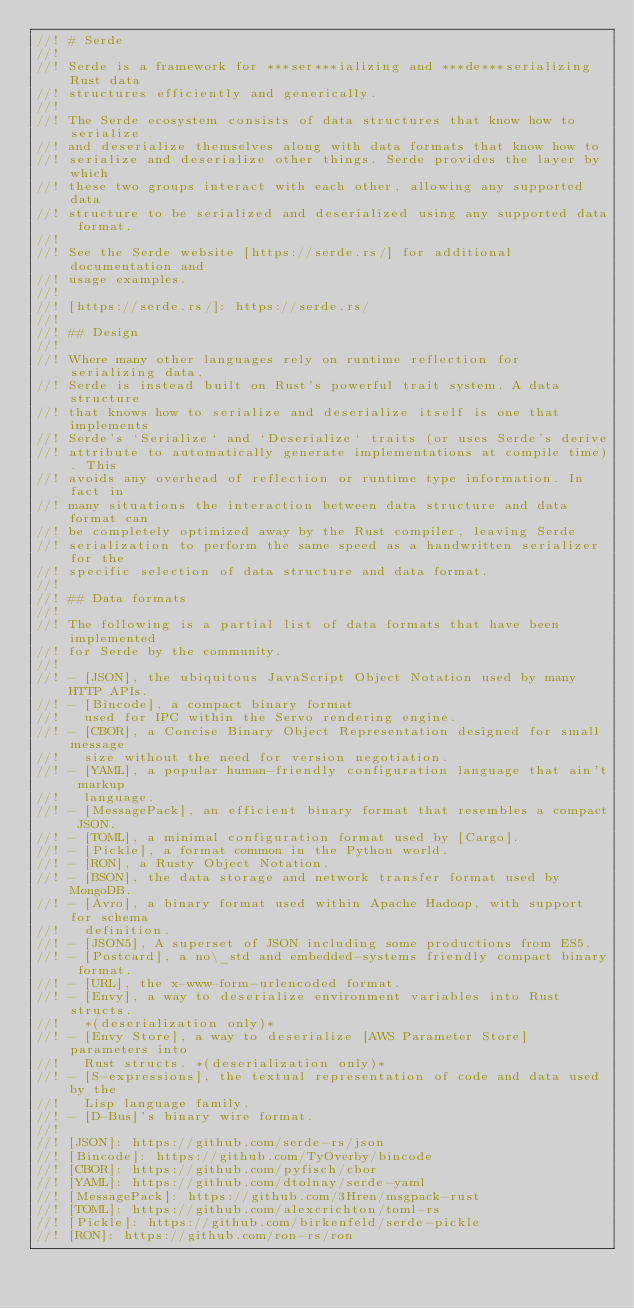Convert code to text. <code><loc_0><loc_0><loc_500><loc_500><_Rust_>//! # Serde
//!
//! Serde is a framework for ***ser***ializing and ***de***serializing Rust data
//! structures efficiently and generically.
//!
//! The Serde ecosystem consists of data structures that know how to serialize
//! and deserialize themselves along with data formats that know how to
//! serialize and deserialize other things. Serde provides the layer by which
//! these two groups interact with each other, allowing any supported data
//! structure to be serialized and deserialized using any supported data format.
//!
//! See the Serde website [https://serde.rs/] for additional documentation and
//! usage examples.
//!
//! [https://serde.rs/]: https://serde.rs/
//!
//! ## Design
//!
//! Where many other languages rely on runtime reflection for serializing data,
//! Serde is instead built on Rust's powerful trait system. A data structure
//! that knows how to serialize and deserialize itself is one that implements
//! Serde's `Serialize` and `Deserialize` traits (or uses Serde's derive
//! attribute to automatically generate implementations at compile time). This
//! avoids any overhead of reflection or runtime type information. In fact in
//! many situations the interaction between data structure and data format can
//! be completely optimized away by the Rust compiler, leaving Serde
//! serialization to perform the same speed as a handwritten serializer for the
//! specific selection of data structure and data format.
//!
//! ## Data formats
//!
//! The following is a partial list of data formats that have been implemented
//! for Serde by the community.
//!
//! - [JSON], the ubiquitous JavaScript Object Notation used by many HTTP APIs.
//! - [Bincode], a compact binary format
//!   used for IPC within the Servo rendering engine.
//! - [CBOR], a Concise Binary Object Representation designed for small message
//!   size without the need for version negotiation.
//! - [YAML], a popular human-friendly configuration language that ain't markup
//!   language.
//! - [MessagePack], an efficient binary format that resembles a compact JSON.
//! - [TOML], a minimal configuration format used by [Cargo].
//! - [Pickle], a format common in the Python world.
//! - [RON], a Rusty Object Notation.
//! - [BSON], the data storage and network transfer format used by MongoDB.
//! - [Avro], a binary format used within Apache Hadoop, with support for schema
//!   definition.
//! - [JSON5], A superset of JSON including some productions from ES5.
//! - [Postcard], a no\_std and embedded-systems friendly compact binary format.
//! - [URL], the x-www-form-urlencoded format.
//! - [Envy], a way to deserialize environment variables into Rust structs.
//!   *(deserialization only)*
//! - [Envy Store], a way to deserialize [AWS Parameter Store] parameters into
//!   Rust structs. *(deserialization only)*
//! - [S-expressions], the textual representation of code and data used by the
//!   Lisp language family.
//! - [D-Bus]'s binary wire format.
//!
//! [JSON]: https://github.com/serde-rs/json
//! [Bincode]: https://github.com/TyOverby/bincode
//! [CBOR]: https://github.com/pyfisch/cbor
//! [YAML]: https://github.com/dtolnay/serde-yaml
//! [MessagePack]: https://github.com/3Hren/msgpack-rust
//! [TOML]: https://github.com/alexcrichton/toml-rs
//! [Pickle]: https://github.com/birkenfeld/serde-pickle
//! [RON]: https://github.com/ron-rs/ron</code> 